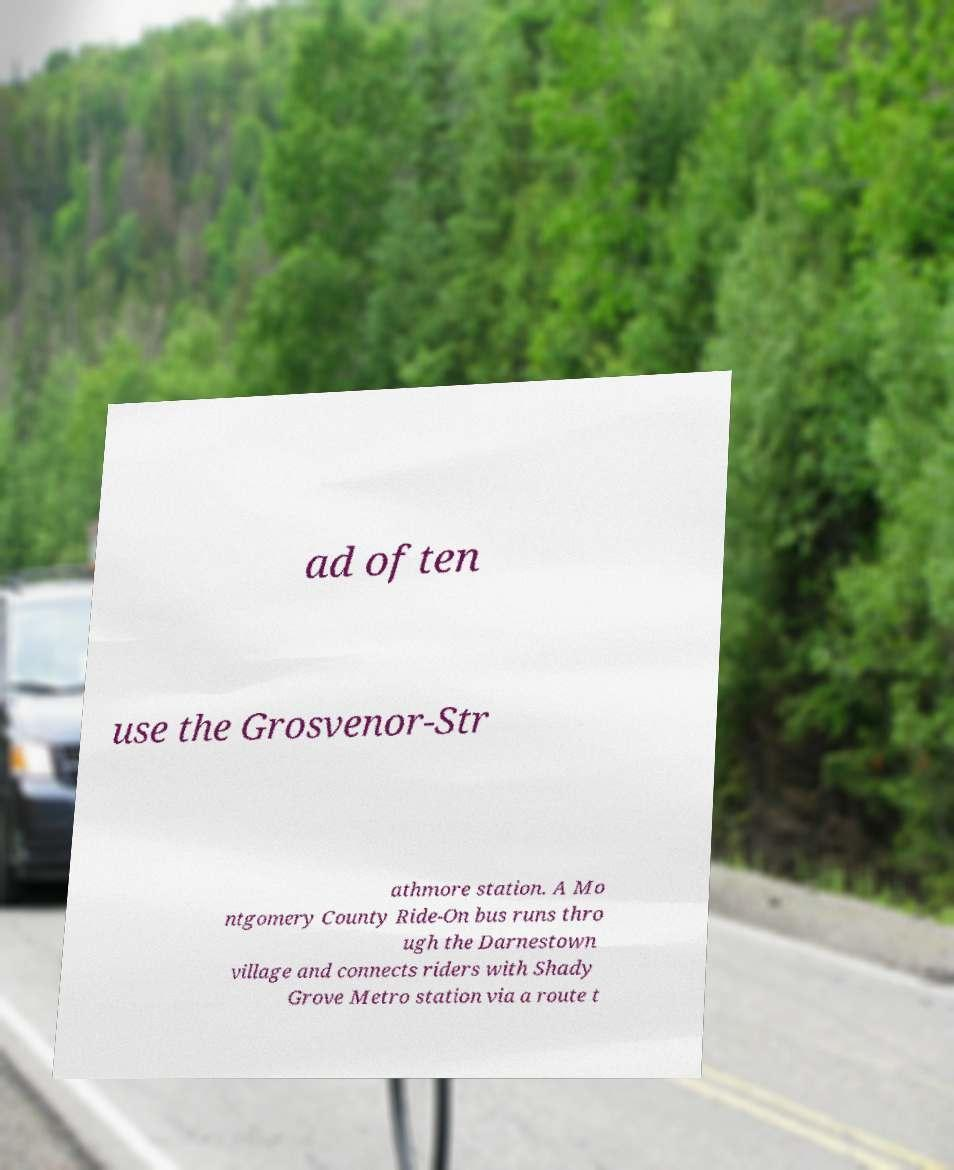Can you read and provide the text displayed in the image?This photo seems to have some interesting text. Can you extract and type it out for me? ad often use the Grosvenor-Str athmore station. A Mo ntgomery County Ride-On bus runs thro ugh the Darnestown village and connects riders with Shady Grove Metro station via a route t 